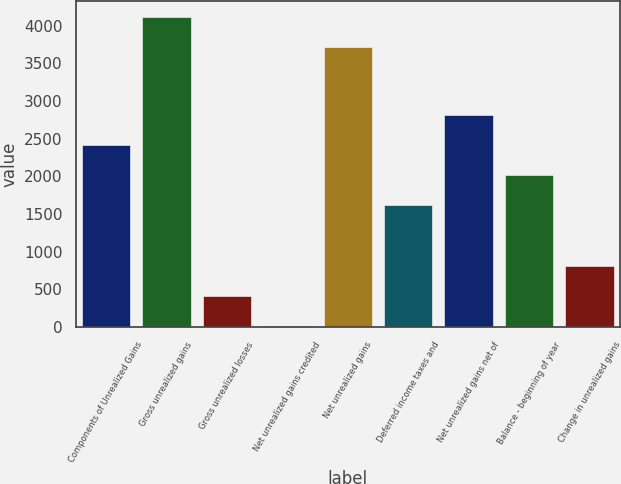Convert chart to OTSL. <chart><loc_0><loc_0><loc_500><loc_500><bar_chart><fcel>Components of Unrealized Gains<fcel>Gross unrealized gains<fcel>Gross unrealized losses<fcel>Net unrealized gains credited<fcel>Net unrealized gains<fcel>Deferred income taxes and<fcel>Net unrealized gains net of<fcel>Balance - beginning of year<fcel>Change in unrealized gains<nl><fcel>2414.6<fcel>4118.3<fcel>417.3<fcel>20<fcel>3721<fcel>1620<fcel>2811.9<fcel>2017.3<fcel>814.6<nl></chart> 